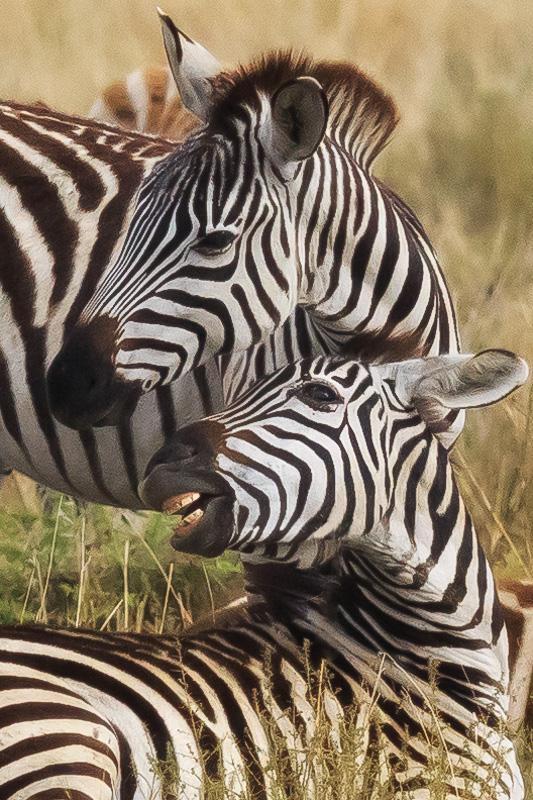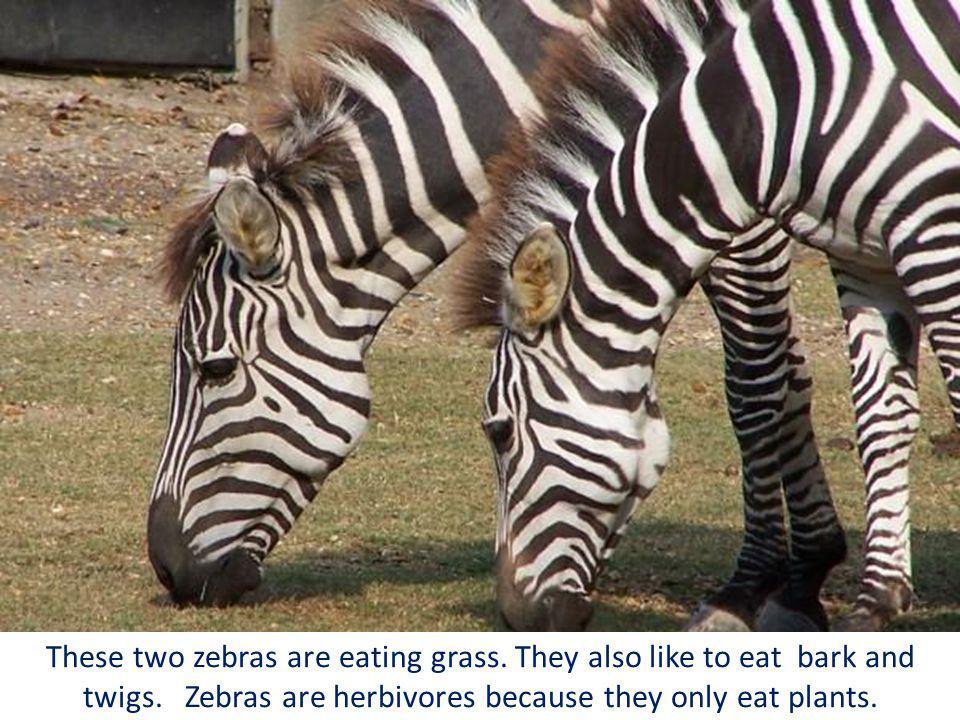The first image is the image on the left, the second image is the image on the right. Given the left and right images, does the statement "In the left image two zebras are facing in opposite directions." hold true? Answer yes or no. No. The first image is the image on the left, the second image is the image on the right. Analyze the images presented: Is the assertion "Each image has two zebras and in only one of the images are they looking in the same direction." valid? Answer yes or no. No. 